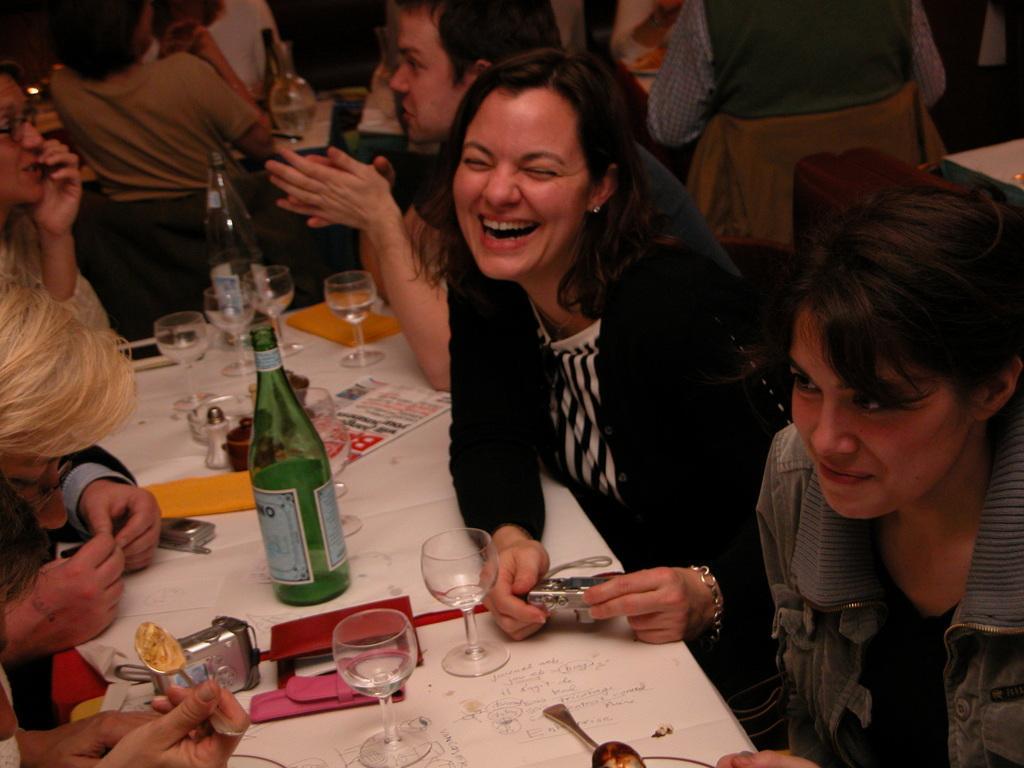Can you describe this image briefly? In this image, we can see people and some are smiling and holding objects in their hands and we can see bottles, glasses with drink, papers, spoons and some other objects are on the table. 